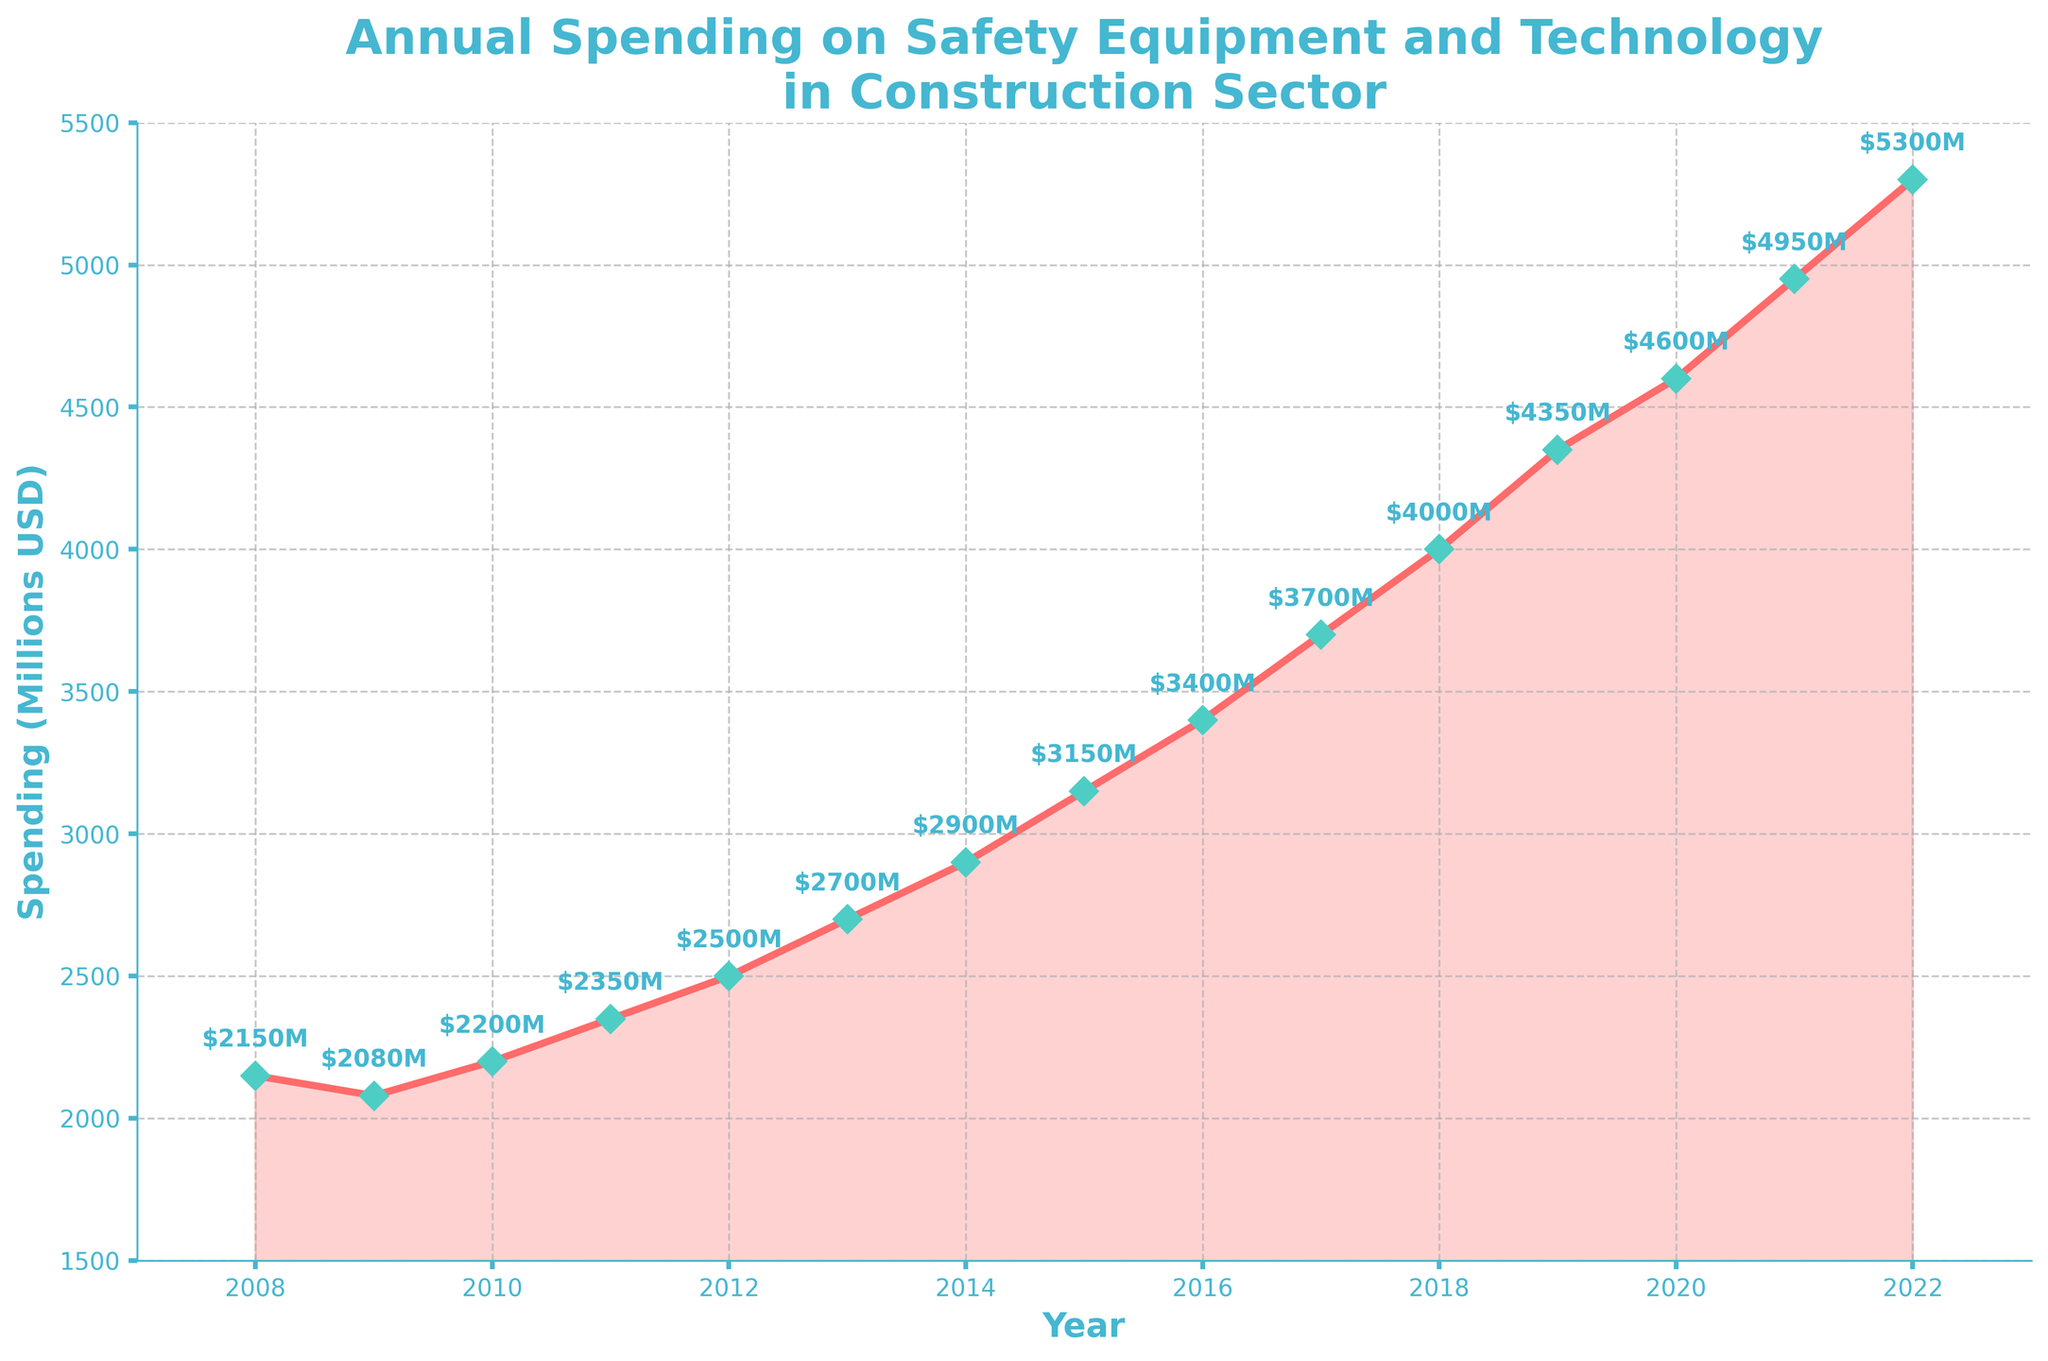What year saw the highest spending on safety equipment and technology? The highest spending on safety equipment and technology can be determined by identifying the peak value in the data points plotted on the graph. The peak value is $5300M in 2022.
Answer: 2022 What is the difference in spending between 2008 and 2015? To find the difference, locate the spending amounts for 2008 and 2015 on the graph. The values are $2150M and $3150M respectively. Subtract the value for 2008 from the value for 2015: $3150M - $2150M = $1000M.
Answer: $1000M Between which two consecutive years is the largest increase in spending observed? To find the largest increase, calculate the differences in spending between each pair of consecutive years. The largest increase is between 2020 ($4600M) and 2021 ($4950M), which is $4950M - $4600M = $350M.
Answer: 2020 and 2021 What is the average annual spending from 2010 to 2014? Calculate the average by adding the spending values from 2010 to 2014 and then dividing by the number of years. The values are $2200M, $2350M, $2500M, $2700M, and $2900M. Sum them: $2200M + $2350M + $2500M + $2700M + $2900M = $12650M. Divide by 5: $12650M / 5 = $2530M.
Answer: $2530M During which years did the spending consistently increase year-on-year? Observe the line on the graph to see where there is a consistent upward trend without any drops. From 2011 until 2022, the spending increases every year.
Answer: 2011 to 2022 By how much did the spending increase from 2009 to 2022? Locate the spending values for 2009 and 2022 on the graph, which are $2080M and $5300M respectively. Subtract the value for 2009 from the value for 2022: $5300M - $2080M = $3220M.
Answer: $3220M What is the median annual spending for the entire period? To find the median spending, list all the spending values in ascending order and find the middle value. The values are $2080M, $2150M, $2200M, $2350M, $2500M, $2700M, $2900M, $3150M, $3400M, $3700M, $4000M, $4350M, $4600M, $4950M, and $5300M. The middle value (8th in the ordered list) is $3150M.
Answer: $3150M What color are the data markers on the plot? The color of the data markers are visually distinguishable on the plot. According to the description, they are light blue with a green edge.
Answer: Light blue with green edge How many steps does the plot use to annotate the spending values? By examining the plot, it includes small text annotations above each data point representing the exact spending values. Count the number of data points with annotations, which equals the total number of years (15).
Answer: 15 